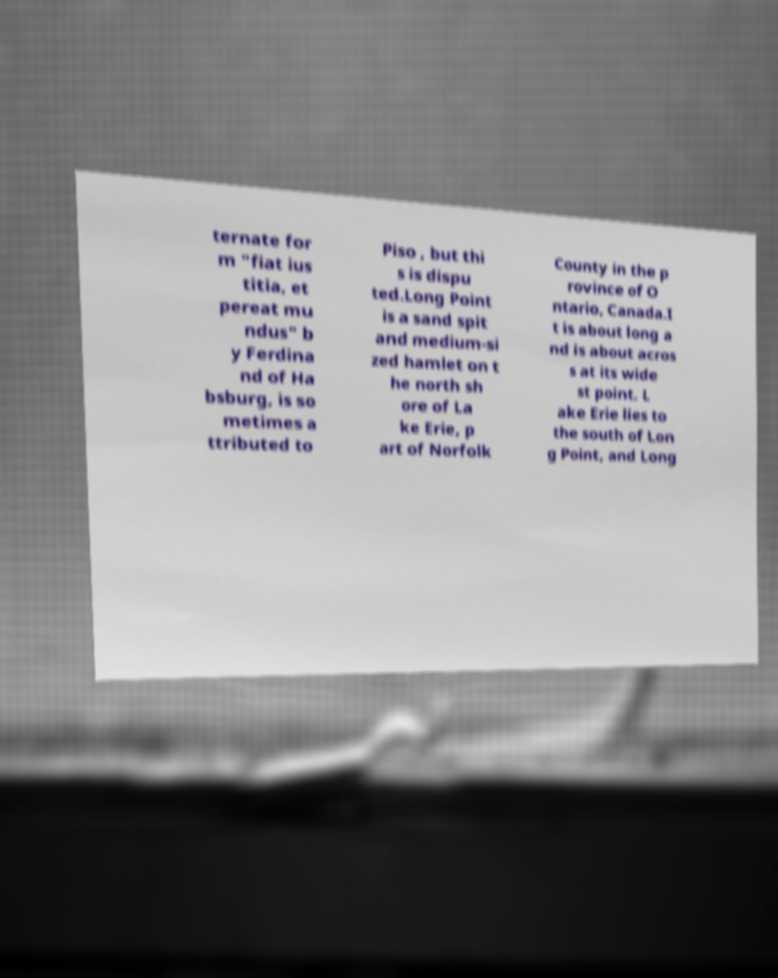Please read and relay the text visible in this image. What does it say? ternate for m "fiat ius titia, et pereat mu ndus" b y Ferdina nd of Ha bsburg, is so metimes a ttributed to Piso , but thi s is dispu ted.Long Point is a sand spit and medium-si zed hamlet on t he north sh ore of La ke Erie, p art of Norfolk County in the p rovince of O ntario, Canada.I t is about long a nd is about acros s at its wide st point. L ake Erie lies to the south of Lon g Point, and Long 